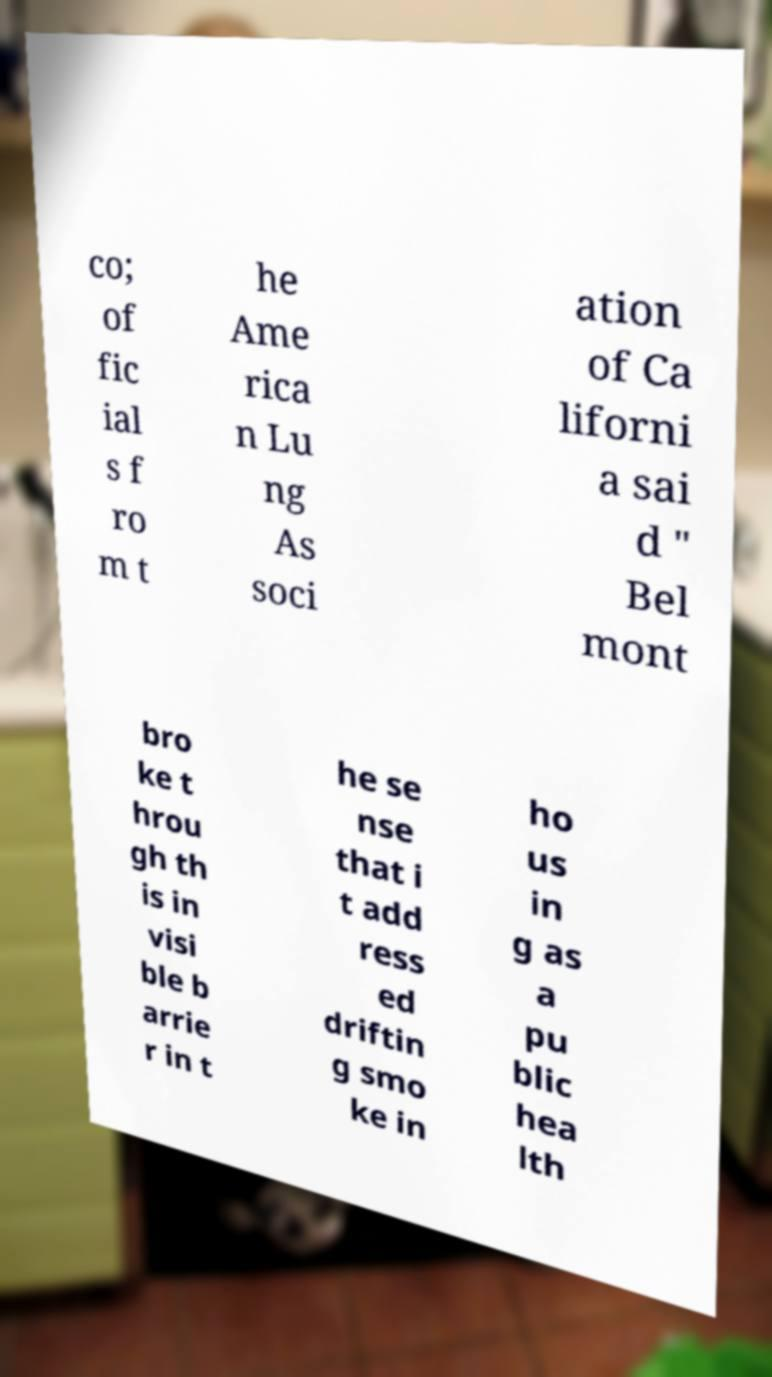For documentation purposes, I need the text within this image transcribed. Could you provide that? co; of fic ial s f ro m t he Ame rica n Lu ng As soci ation of Ca liforni a sai d " Bel mont bro ke t hrou gh th is in visi ble b arrie r in t he se nse that i t add ress ed driftin g smo ke in ho us in g as a pu blic hea lth 